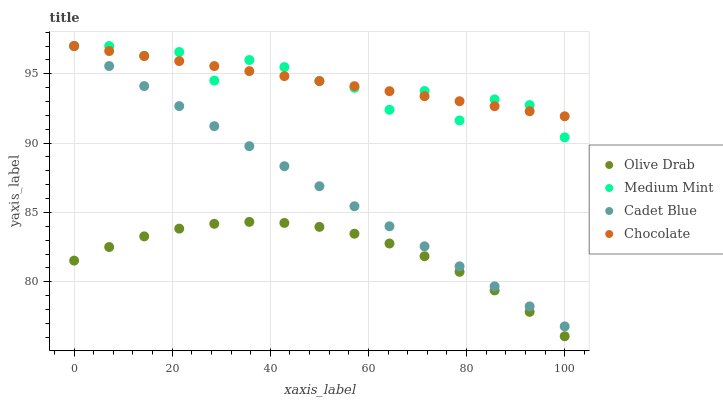Does Olive Drab have the minimum area under the curve?
Answer yes or no. Yes. Does Chocolate have the maximum area under the curve?
Answer yes or no. Yes. Does Cadet Blue have the minimum area under the curve?
Answer yes or no. No. Does Cadet Blue have the maximum area under the curve?
Answer yes or no. No. Is Cadet Blue the smoothest?
Answer yes or no. Yes. Is Medium Mint the roughest?
Answer yes or no. Yes. Is Olive Drab the smoothest?
Answer yes or no. No. Is Olive Drab the roughest?
Answer yes or no. No. Does Olive Drab have the lowest value?
Answer yes or no. Yes. Does Cadet Blue have the lowest value?
Answer yes or no. No. Does Chocolate have the highest value?
Answer yes or no. Yes. Does Olive Drab have the highest value?
Answer yes or no. No. Is Olive Drab less than Cadet Blue?
Answer yes or no. Yes. Is Medium Mint greater than Olive Drab?
Answer yes or no. Yes. Does Cadet Blue intersect Chocolate?
Answer yes or no. Yes. Is Cadet Blue less than Chocolate?
Answer yes or no. No. Is Cadet Blue greater than Chocolate?
Answer yes or no. No. Does Olive Drab intersect Cadet Blue?
Answer yes or no. No. 